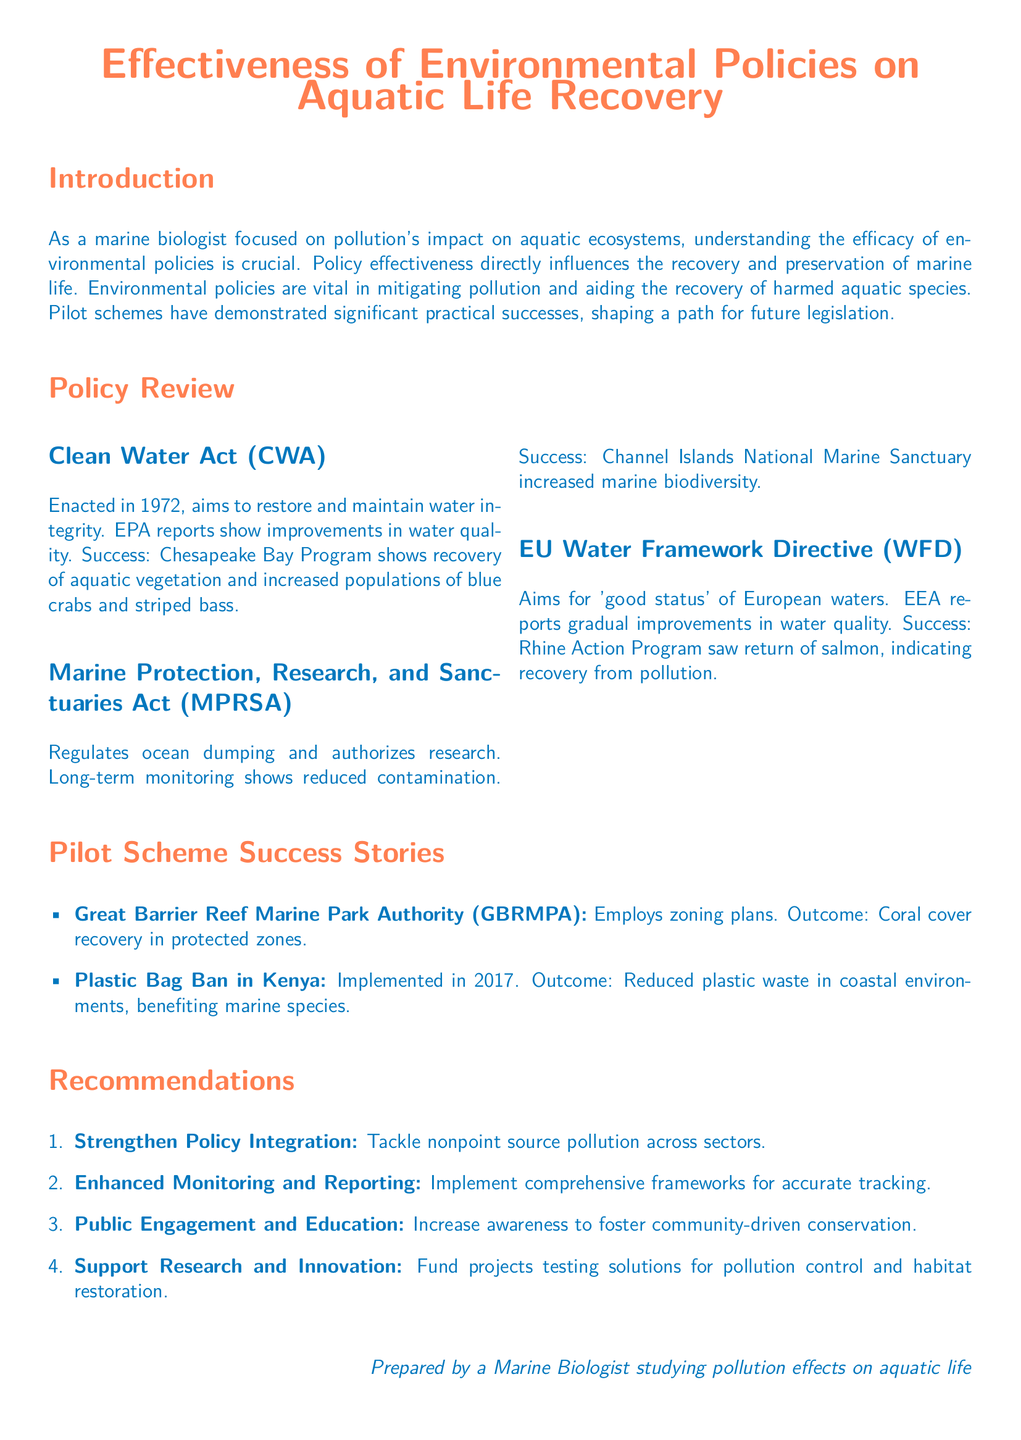What year was the Clean Water Act enacted? The document states that the Clean Water Act was enacted in 1972.
Answer: 1972 What is the main goal of the EU Water Framework Directive? The EU Water Framework Directive aims for 'good status' of European waters.
Answer: good status What did the Chesapeake Bay Program demonstrate in terms of recovery? The Chesapeake Bay Program shows recovery of aquatic vegetation and increased populations of blue crabs and striped bass.
Answer: recovery of aquatic vegetation and increased populations of blue crabs and striped bass What type of pollution does the recommendation suggest to strengthen integration against? The recommendation suggests tackling nonpoint source pollution across sectors.
Answer: nonpoint source pollution Which marine sanctuary reported increased biodiversity? The Channel Islands National Marine Sanctuary reported increased marine biodiversity.
Answer: Channel Islands National Marine Sanctuary How many recommendations are provided in the document? The document lists four recommendations.
Answer: four What was the outcome of the Plastic Bag Ban in Kenya? The outcome of the Plastic Bag Ban was reduced plastic waste in coastal environments, benefiting marine species.
Answer: Reduced plastic waste in coastal environments What is the purpose of the Marine Protection, Research, and Sanctuaries Act? The Marine Protection, Research, and Sanctuaries Act regulates ocean dumping and authorizes research.
Answer: Regulates ocean dumping and authorizes research What is emphasized under Enhanced Monitoring and Reporting recommendation? It emphasizes implementing comprehensive frameworks for accurate tracking.
Answer: Comprehensive frameworks for accurate tracking 